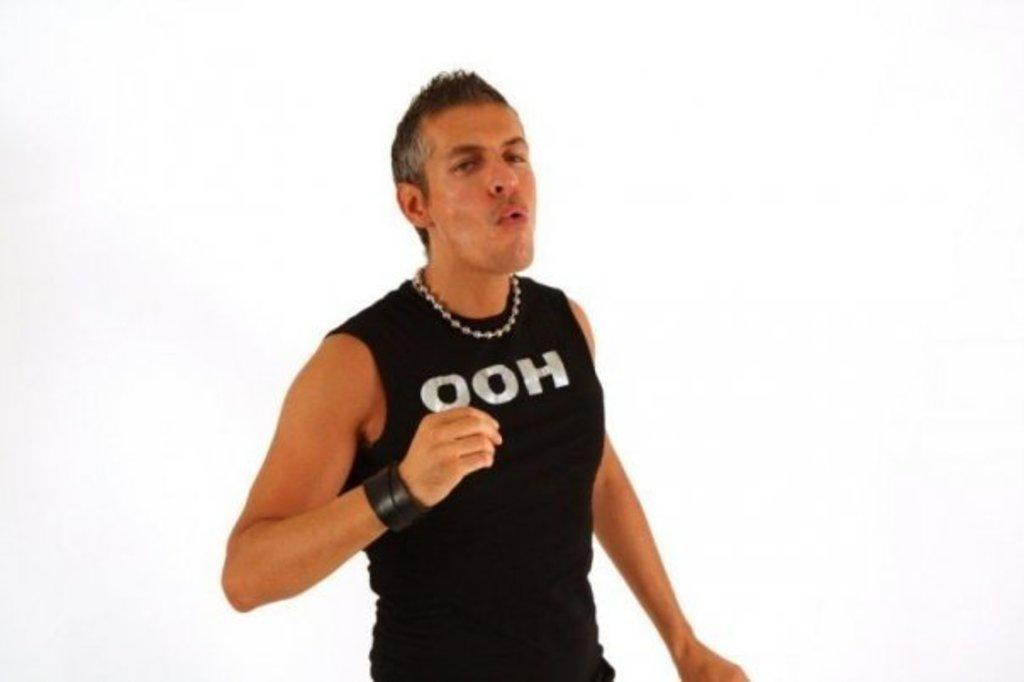<image>
Create a compact narrative representing the image presented. a person that has the letters ooh on their shirt 